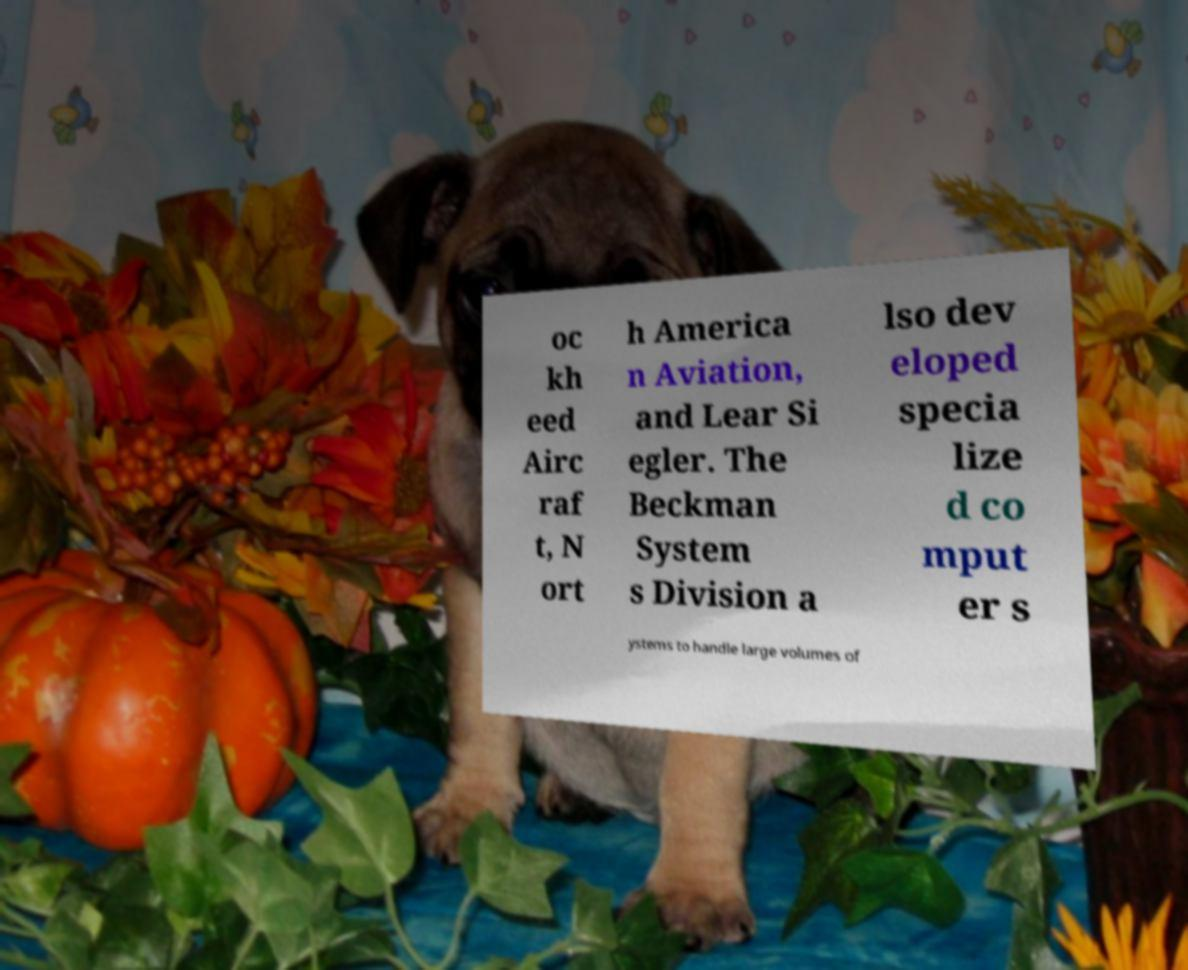Could you assist in decoding the text presented in this image and type it out clearly? oc kh eed Airc raf t, N ort h America n Aviation, and Lear Si egler. The Beckman System s Division a lso dev eloped specia lize d co mput er s ystems to handle large volumes of 